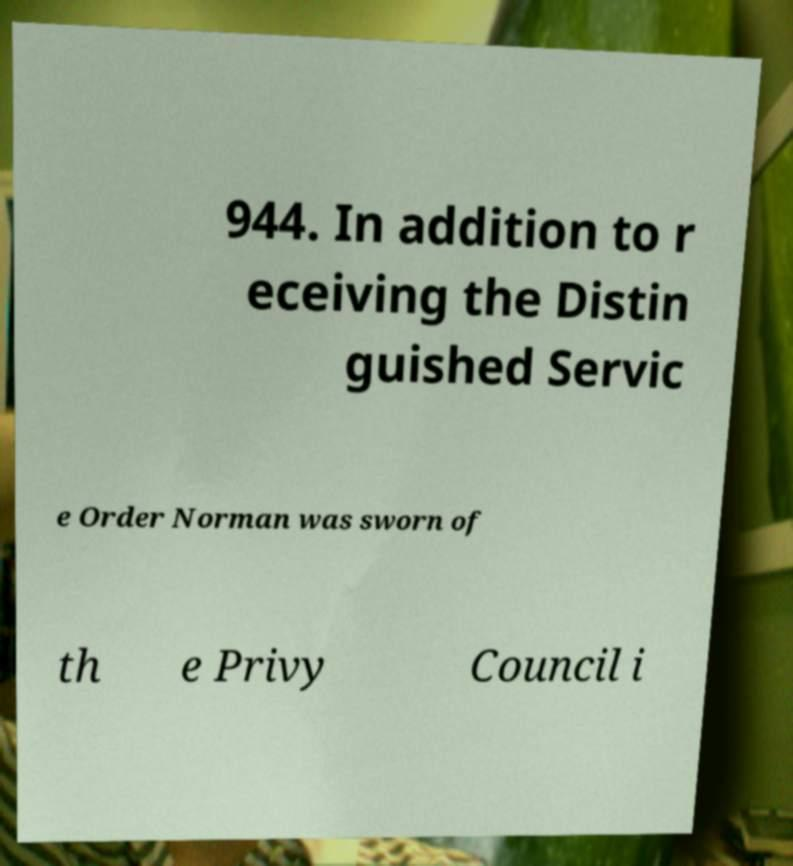Could you extract and type out the text from this image? 944. In addition to r eceiving the Distin guished Servic e Order Norman was sworn of th e Privy Council i 